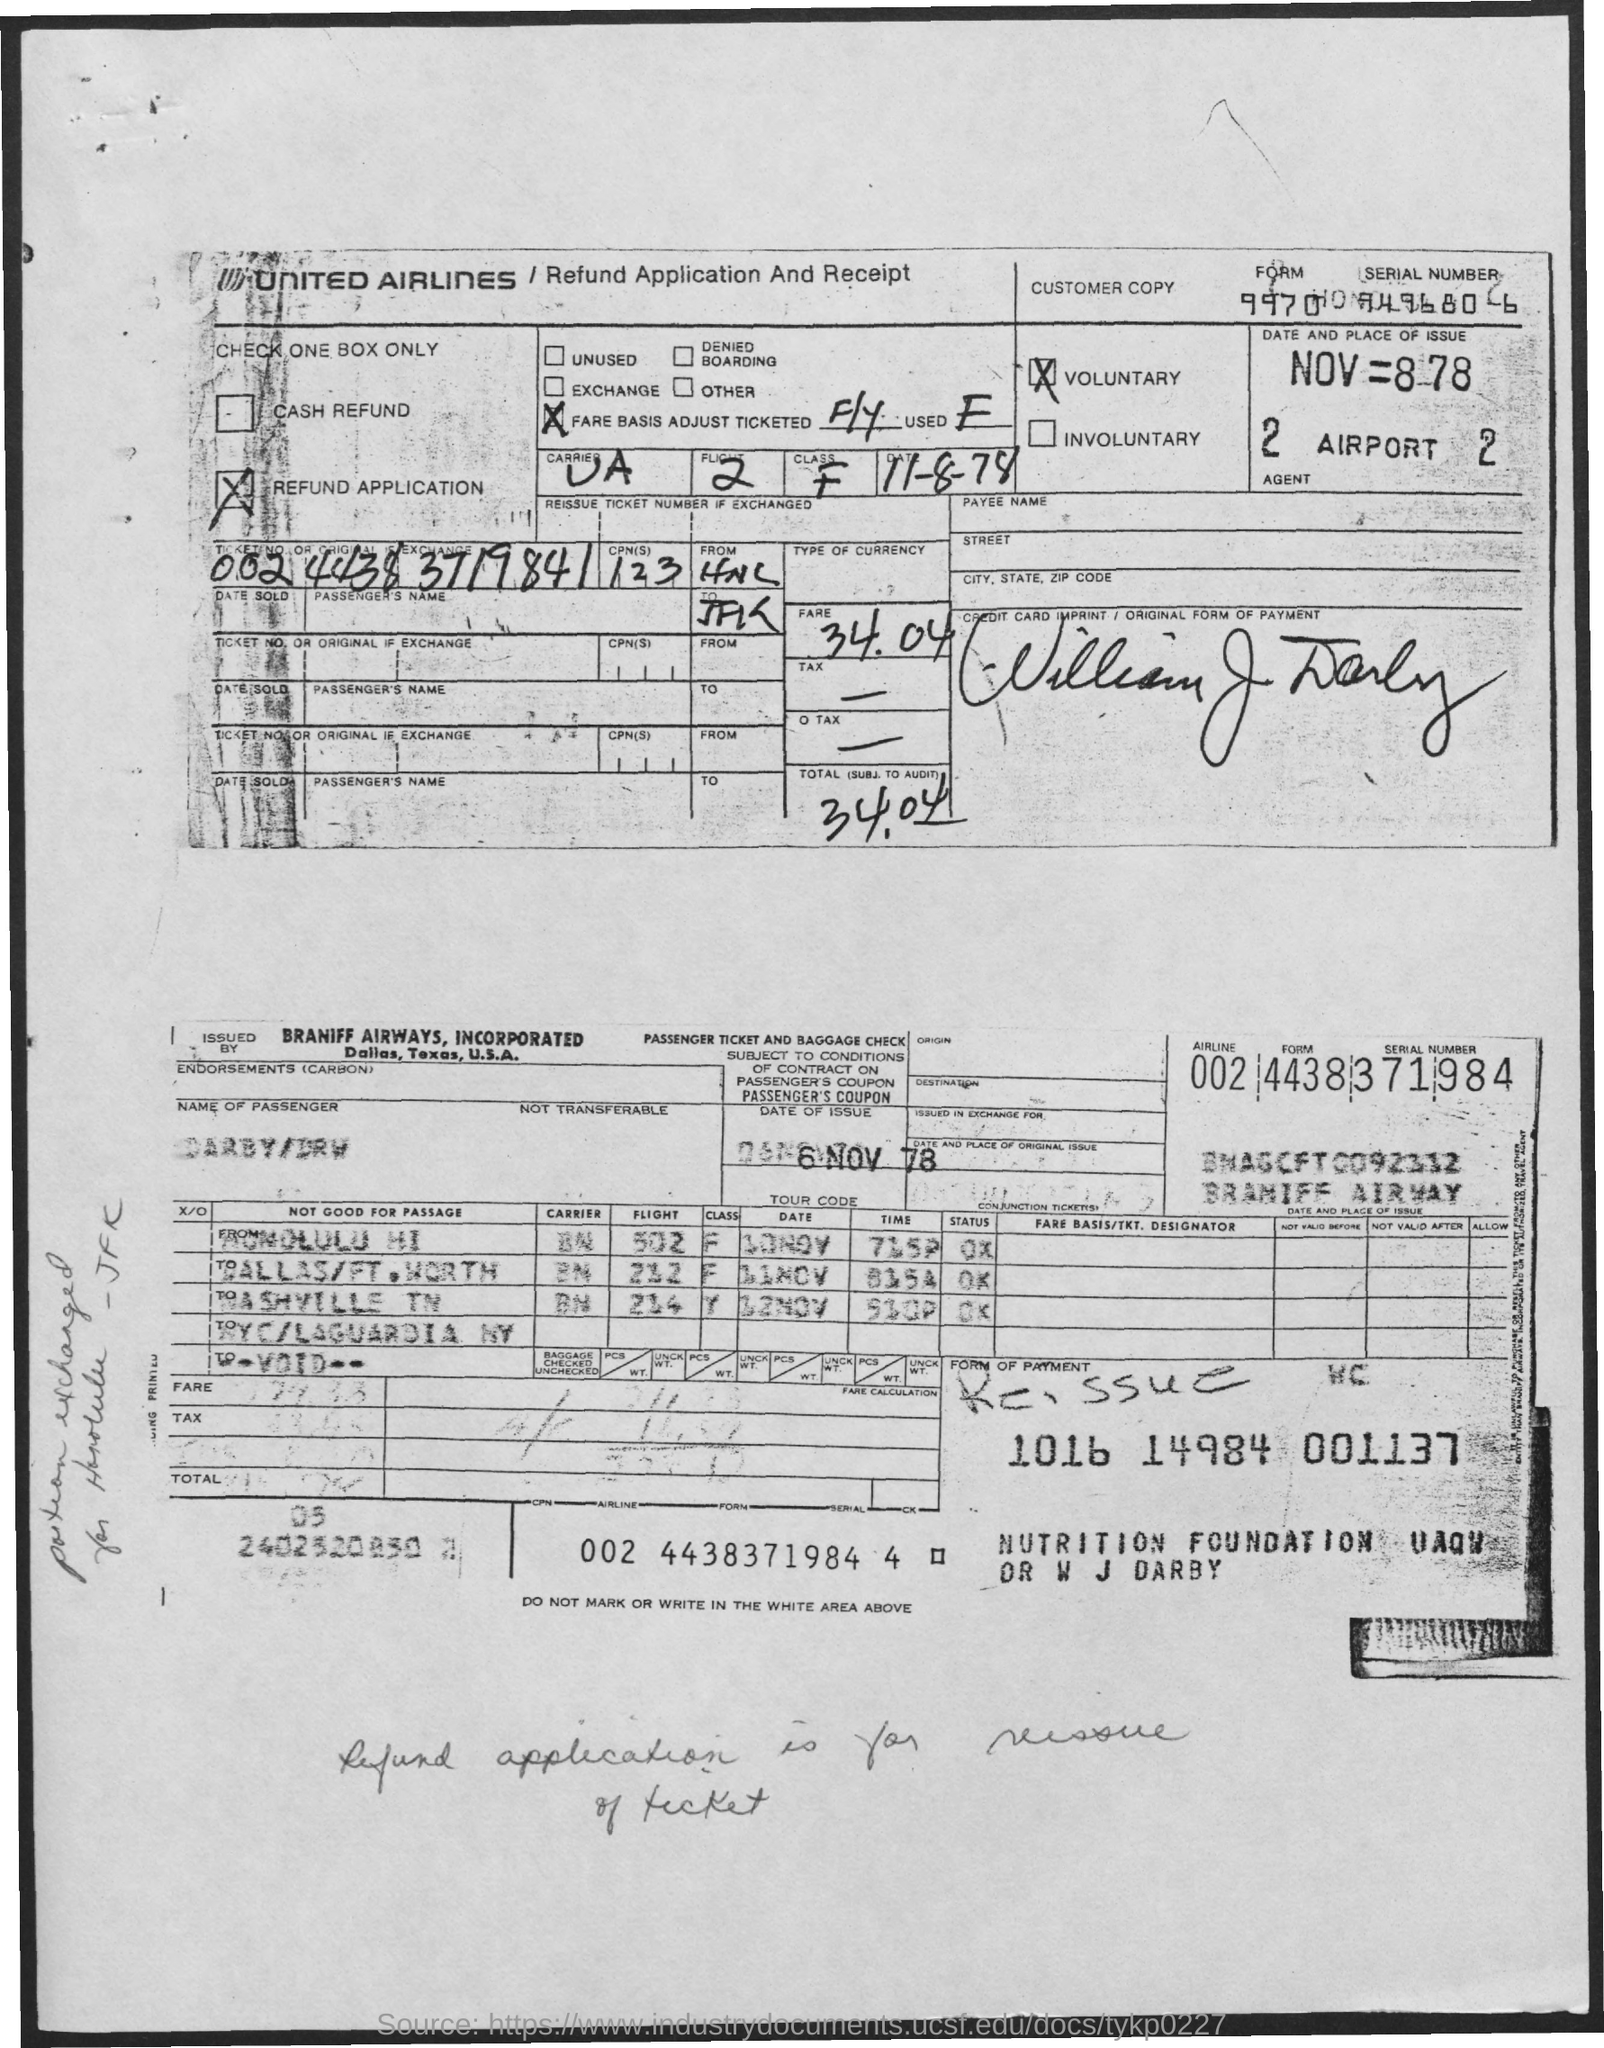Mention a couple of crucial points in this snapshot. The refund application has a form number of 9970. The fare specified is 34.04... This is a refund application and receipt form. United Airlines is mentioned. It is voluntary, not involuntary. 